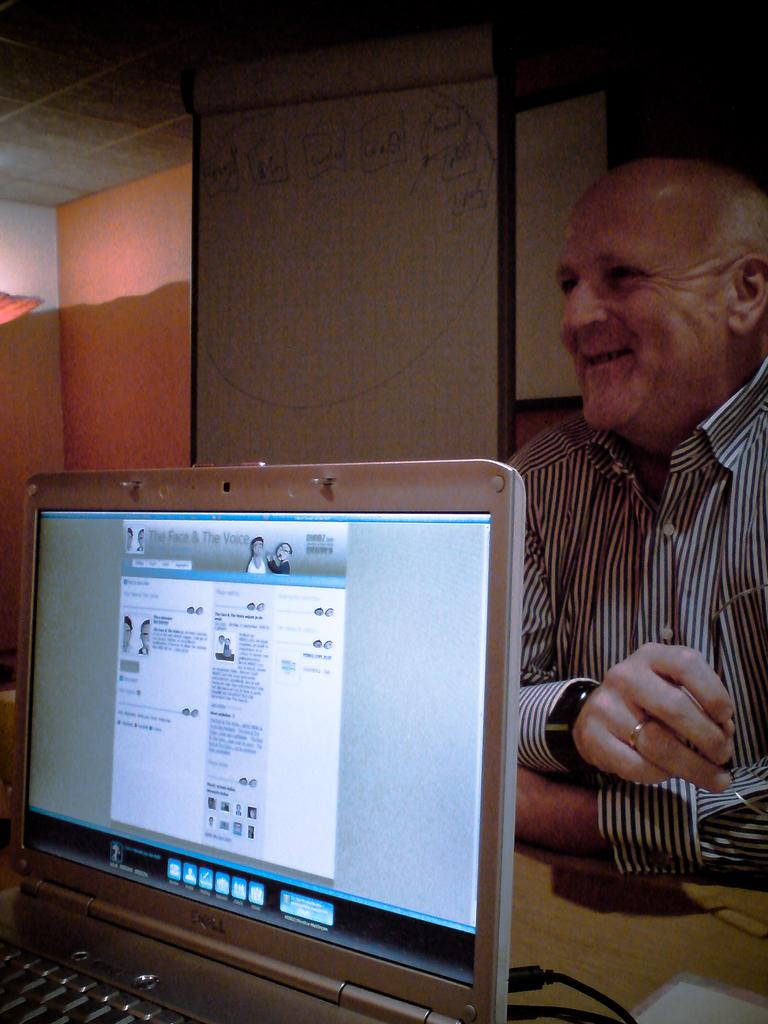Who or what is present in the image? There is a person in the image. What object can be seen in the image? There is an object in the image, but the specific object is not mentioned in the facts. Where is the laptop located in the image? The laptop is on a table in the image. What is the purpose of the projector screen in the image? The projector screen is likely used for displaying visuals during a presentation or meeting. What is the whiteboard used for in the image? The whiteboard is likely used for writing notes, drawing diagrams, or displaying information during a presentation or meeting. What color is the woman's scarf in the image? There is no woman or scarf present in the image. How many teeth can be seen on the person in the image? There is no indication of the person's teeth in the image. 